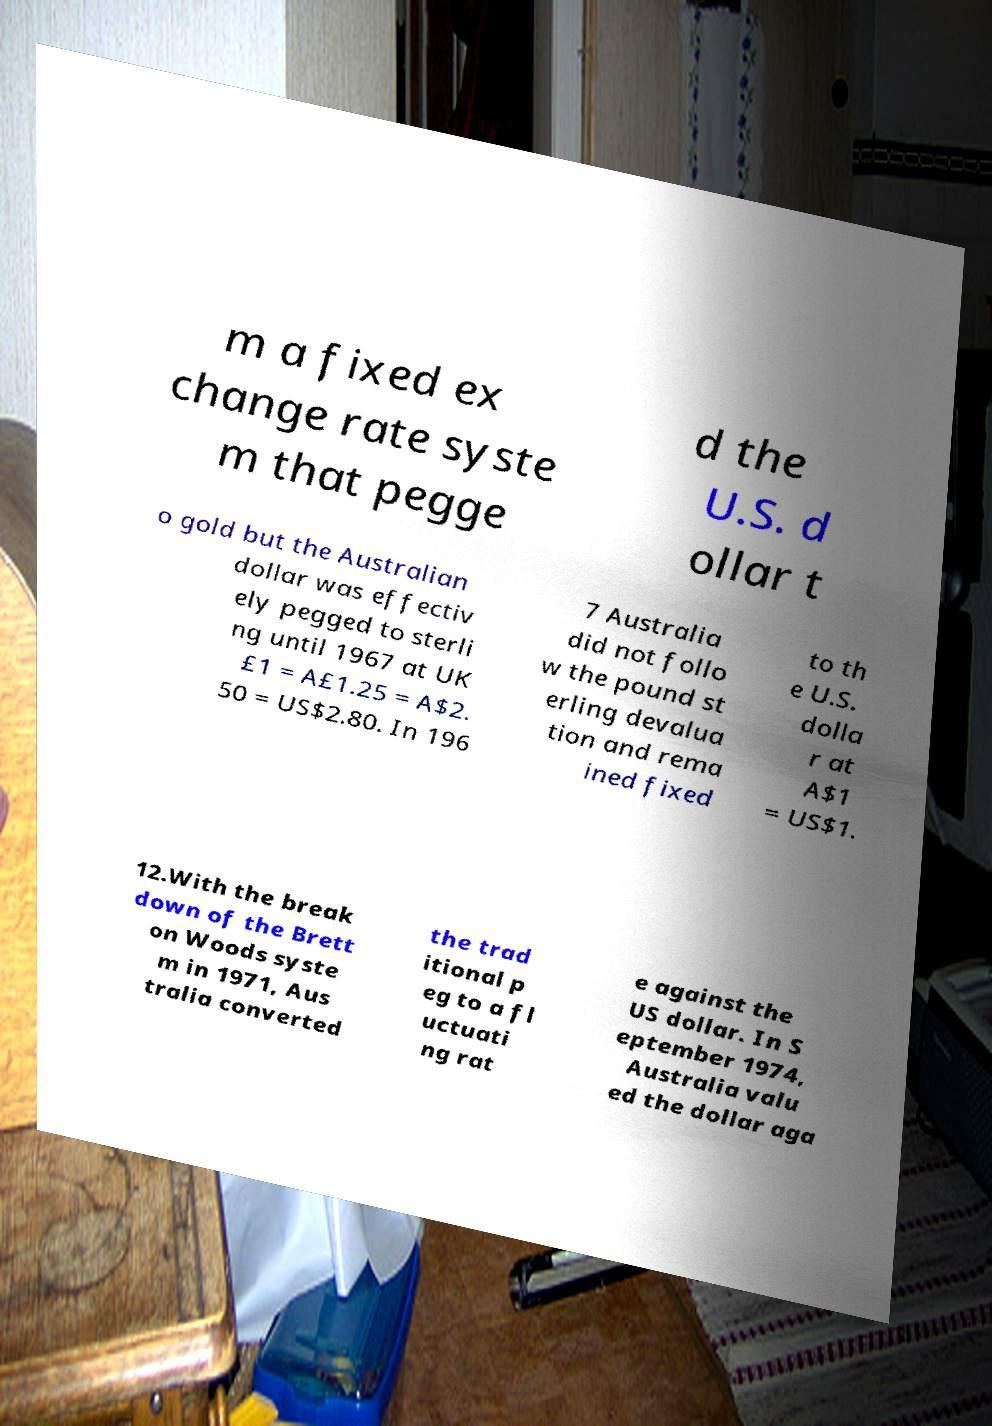For documentation purposes, I need the text within this image transcribed. Could you provide that? m a fixed ex change rate syste m that pegge d the U.S. d ollar t o gold but the Australian dollar was effectiv ely pegged to sterli ng until 1967 at UK £1 = A£1.25 = A$2. 50 = US$2.80. In 196 7 Australia did not follo w the pound st erling devalua tion and rema ined fixed to th e U.S. dolla r at A$1 = US$1. 12.With the break down of the Brett on Woods syste m in 1971, Aus tralia converted the trad itional p eg to a fl uctuati ng rat e against the US dollar. In S eptember 1974, Australia valu ed the dollar aga 